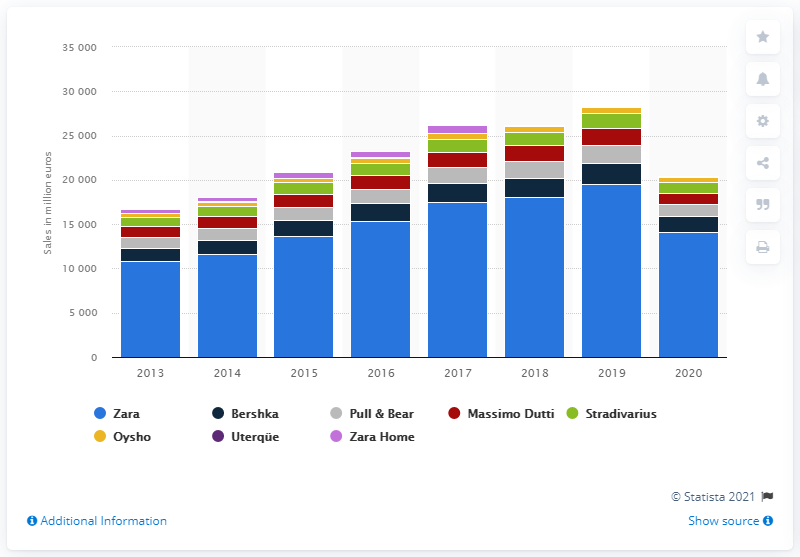List a handful of essential elements in this visual. The net sales of Zara from 2013 to 2020 were 14,129 and. 